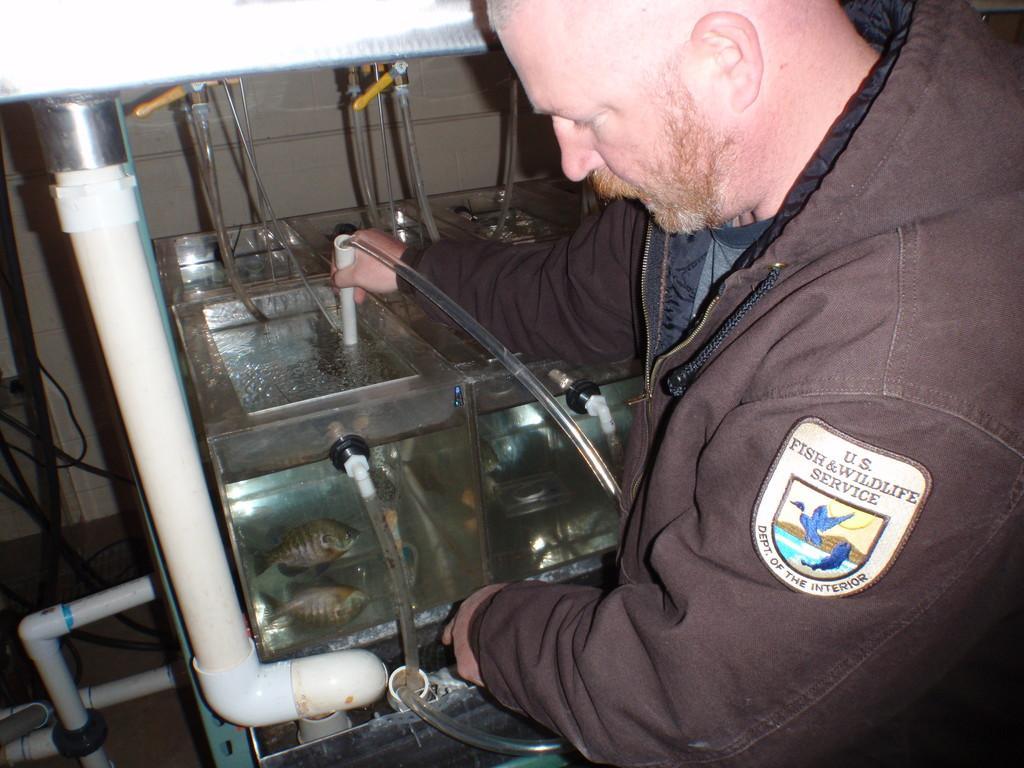In one or two sentences, can you explain what this image depicts? In this image there is a man standing. He is holding a pipe. In front of him there are aquariums. There are fishes in the aquarium. There are pipes and cables wires beside the aquarium. In the background there is the wall. 